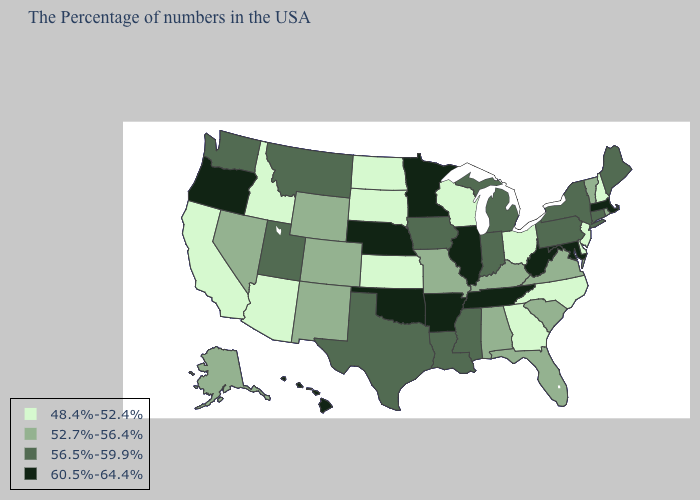Name the states that have a value in the range 56.5%-59.9%?
Quick response, please. Maine, Connecticut, New York, Pennsylvania, Michigan, Indiana, Mississippi, Louisiana, Iowa, Texas, Utah, Montana, Washington. Does Arizona have the lowest value in the West?
Answer briefly. Yes. Does Arkansas have a higher value than Wisconsin?
Quick response, please. Yes. What is the value of Alabama?
Give a very brief answer. 52.7%-56.4%. Does Virginia have the same value as Georgia?
Write a very short answer. No. Does the first symbol in the legend represent the smallest category?
Be succinct. Yes. What is the highest value in states that border Idaho?
Concise answer only. 60.5%-64.4%. What is the value of Florida?
Give a very brief answer. 52.7%-56.4%. What is the value of Florida?
Answer briefly. 52.7%-56.4%. What is the value of Ohio?
Quick response, please. 48.4%-52.4%. Is the legend a continuous bar?
Short answer required. No. Name the states that have a value in the range 56.5%-59.9%?
Short answer required. Maine, Connecticut, New York, Pennsylvania, Michigan, Indiana, Mississippi, Louisiana, Iowa, Texas, Utah, Montana, Washington. What is the value of Tennessee?
Write a very short answer. 60.5%-64.4%. What is the value of Nebraska?
Write a very short answer. 60.5%-64.4%. What is the lowest value in states that border Wisconsin?
Answer briefly. 56.5%-59.9%. 